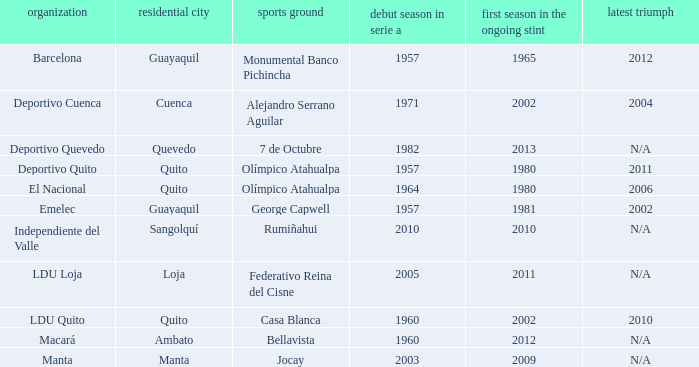Name the club for quevedo Deportivo Quevedo. 